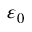Convert formula to latex. <formula><loc_0><loc_0><loc_500><loc_500>\varepsilon _ { 0 }</formula> 